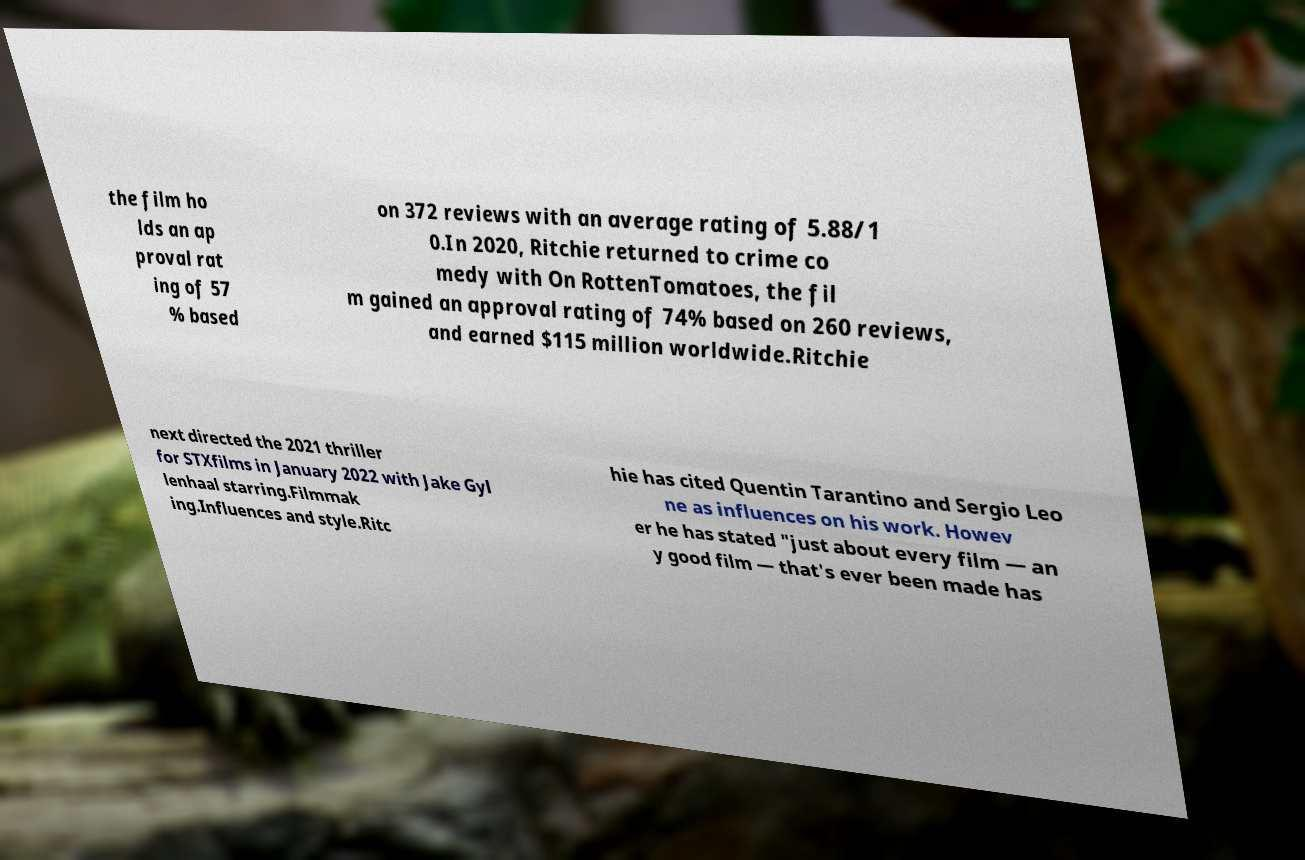Can you accurately transcribe the text from the provided image for me? the film ho lds an ap proval rat ing of 57 % based on 372 reviews with an average rating of 5.88/1 0.In 2020, Ritchie returned to crime co medy with On RottenTomatoes, the fil m gained an approval rating of 74% based on 260 reviews, and earned $115 million worldwide.Ritchie next directed the 2021 thriller for STXfilms in January 2022 with Jake Gyl lenhaal starring.Filmmak ing.Influences and style.Ritc hie has cited Quentin Tarantino and Sergio Leo ne as influences on his work. Howev er he has stated "just about every film — an y good film — that's ever been made has 